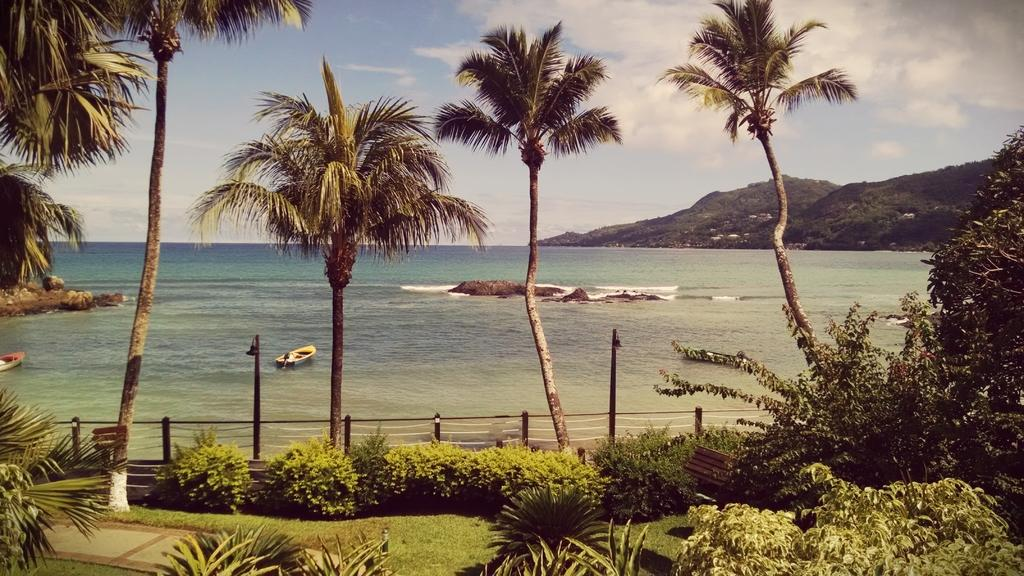What type of vegetation can be seen in the image? There are many trees, plants, and grass visible in the image. What type of pathway is present in the image? There is a walkway in the image. What structures are present in the image? There are poles and fencing visible in the image. What natural features can be seen in the image? The sea, mountains, and sky are visible in the image. What man-made object is present in the water? There is a boat in the image. How does the crib provide comfort to the trees in the image? There is no crib present in the image, and trees do not require comfort. What type of bite can be seen on the boat in the image? There is no bite present on the boat in the image. 